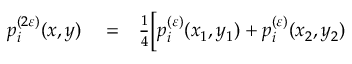<formula> <loc_0><loc_0><loc_500><loc_500>\begin{array} { r l r } { p _ { i } ^ { ( 2 \varepsilon ) } ( x , y ) } & = } & { \frac { 1 } { 4 } \Big [ p _ { i } ^ { ( \varepsilon ) } ( x _ { 1 } , y _ { 1 } ) + p _ { i } ^ { ( \varepsilon ) } ( x _ { 2 } , y _ { 2 } ) } \end{array}</formula> 